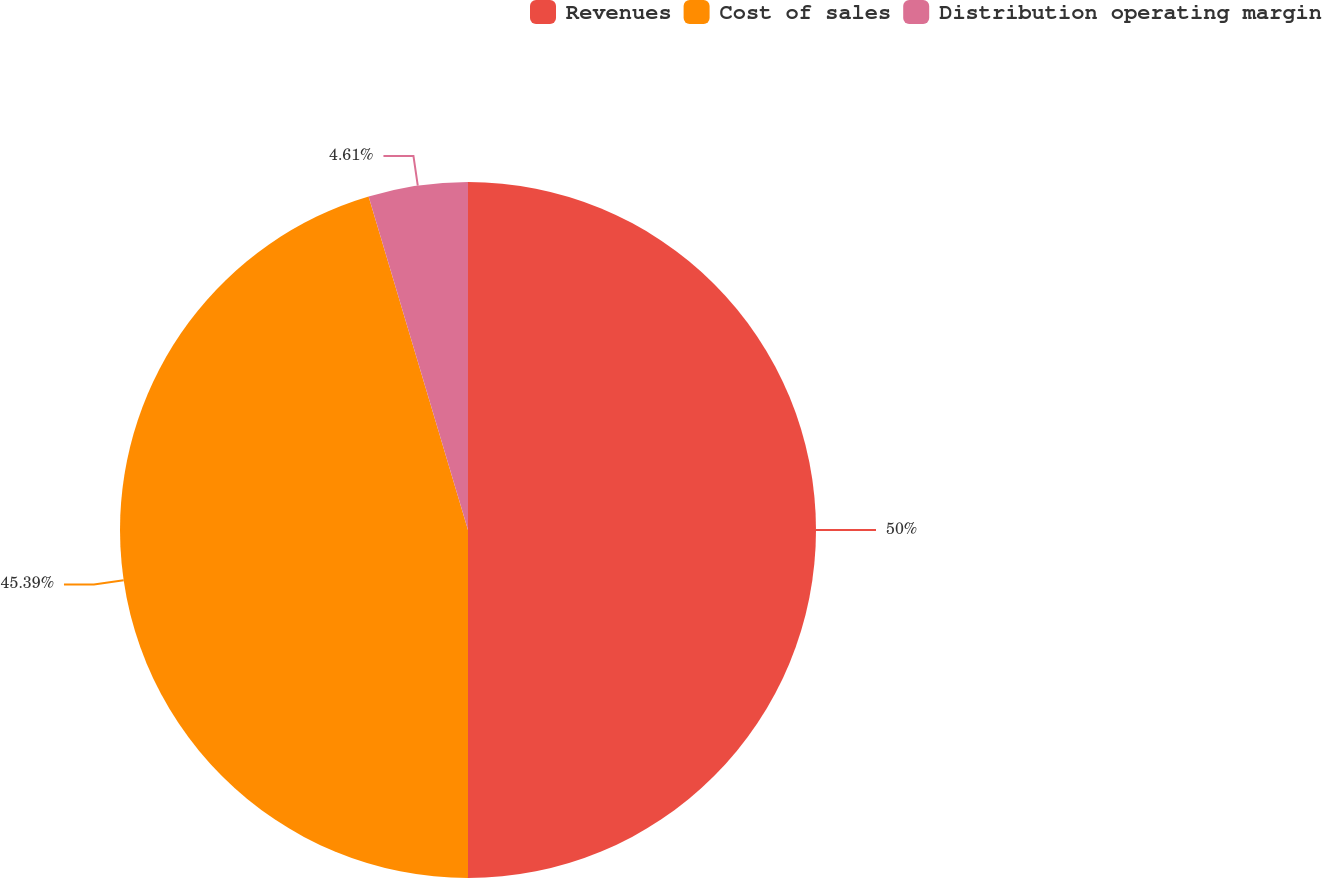Convert chart. <chart><loc_0><loc_0><loc_500><loc_500><pie_chart><fcel>Revenues<fcel>Cost of sales<fcel>Distribution operating margin<nl><fcel>50.0%<fcel>45.39%<fcel>4.61%<nl></chart> 